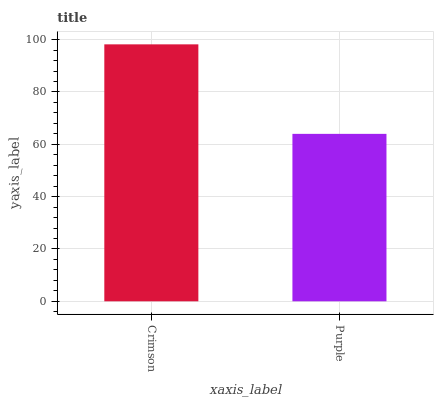Is Purple the minimum?
Answer yes or no. Yes. Is Crimson the maximum?
Answer yes or no. Yes. Is Purple the maximum?
Answer yes or no. No. Is Crimson greater than Purple?
Answer yes or no. Yes. Is Purple less than Crimson?
Answer yes or no. Yes. Is Purple greater than Crimson?
Answer yes or no. No. Is Crimson less than Purple?
Answer yes or no. No. Is Crimson the high median?
Answer yes or no. Yes. Is Purple the low median?
Answer yes or no. Yes. Is Purple the high median?
Answer yes or no. No. Is Crimson the low median?
Answer yes or no. No. 